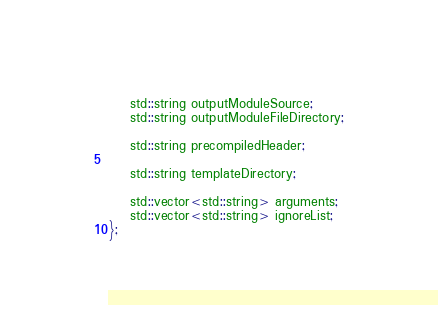<code> <loc_0><loc_0><loc_500><loc_500><_C_>    std::string outputModuleSource;
    std::string outputModuleFileDirectory;

    std::string precompiledHeader;

    std::string templateDirectory;

    std::vector<std::string> arguments;
	std::vector<std::string> ignoreList;
};</code> 